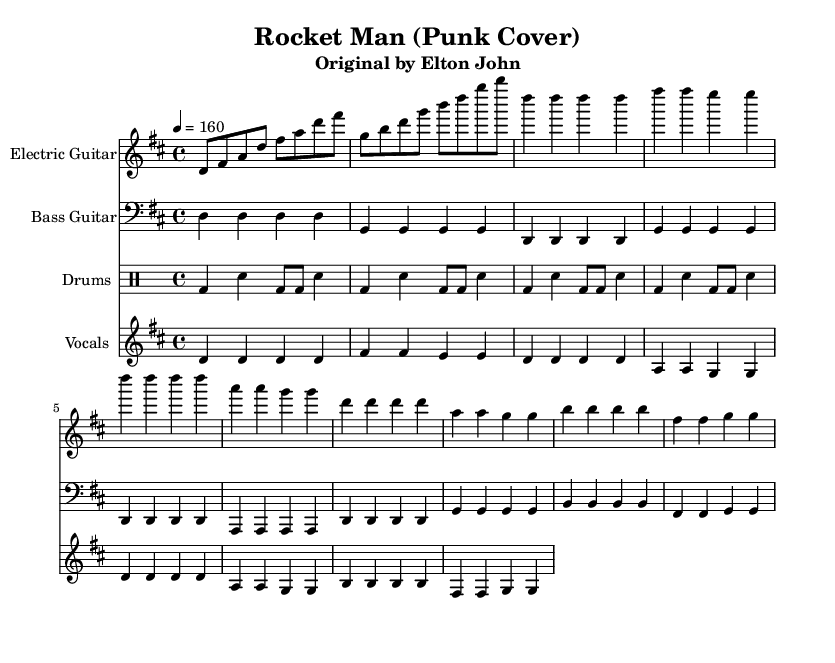What is the key signature of this music? The key signature is D major, which has two sharps (F# and C#). It can be identified by looking at the key signature at the beginning of the staff.
Answer: D major What is the time signature of this music? The time signature is 4/4, which means there are four beats in a measure and the quarter note gets one beat. This can be found at the beginning of the score.
Answer: 4/4 What is the tempo marking for this song? The tempo marking is 160 beats per minute. This is indicated in the score after the time signature.
Answer: 160 Is there a drum pattern present in the score? Yes, there is a basic punk beat indicated in the drumming part, outlined by the bass drum and snare placements. The rhythmic structure is typical for punk music, focusing on a strong backbeat.
Answer: Yes What instrument plays the melody line in this piece? The vocals part represents the melody line in this piece, sung over the instrumental backing. It is marked by the staff labeled "Vocals."
Answer: Vocals How many different instruments are written in this arrangement? There are four different instruments: electric guitar, bass guitar, drums, and vocals, each written on separate staves in the score.
Answer: Four What type of music genre can this arrangement be categorized under? This arrangement can be categorized under Punk, as indicated by the title "Rocket Man (Punk Cover)" and the energetic, upbeat style typical of punk music.
Answer: Punk 